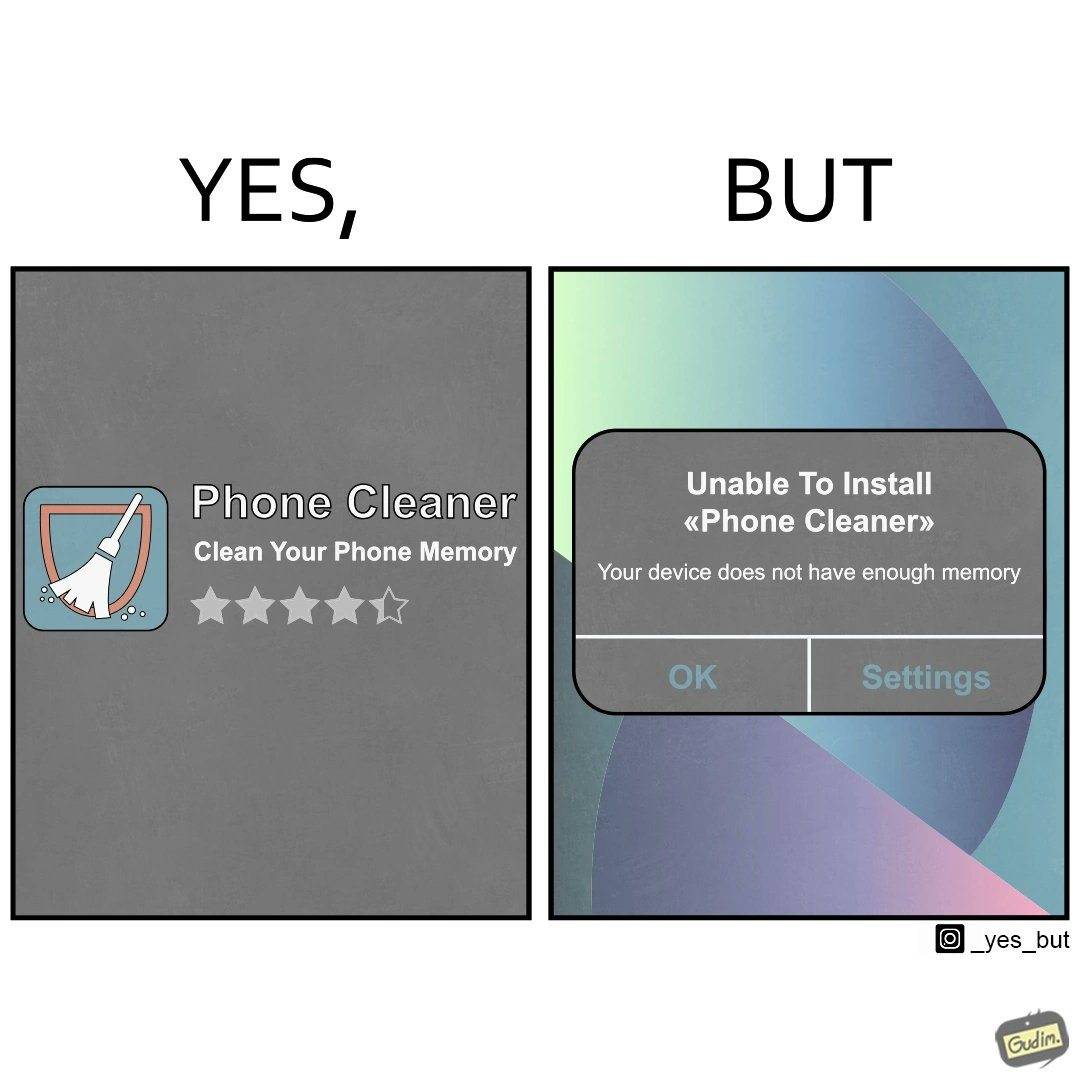Explain why this image is satirical. The image is ironical, as to clear the phone's memory using phone cleaner app, one has to install it, but that is not possible in turn due to the phone memory being full. 